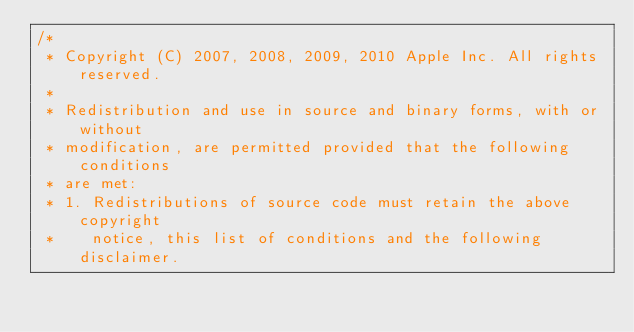Convert code to text. <code><loc_0><loc_0><loc_500><loc_500><_C_>/*
 * Copyright (C) 2007, 2008, 2009, 2010 Apple Inc. All rights reserved.
 *
 * Redistribution and use in source and binary forms, with or without
 * modification, are permitted provided that the following conditions
 * are met:
 * 1. Redistributions of source code must retain the above copyright
 *    notice, this list of conditions and the following disclaimer.</code> 